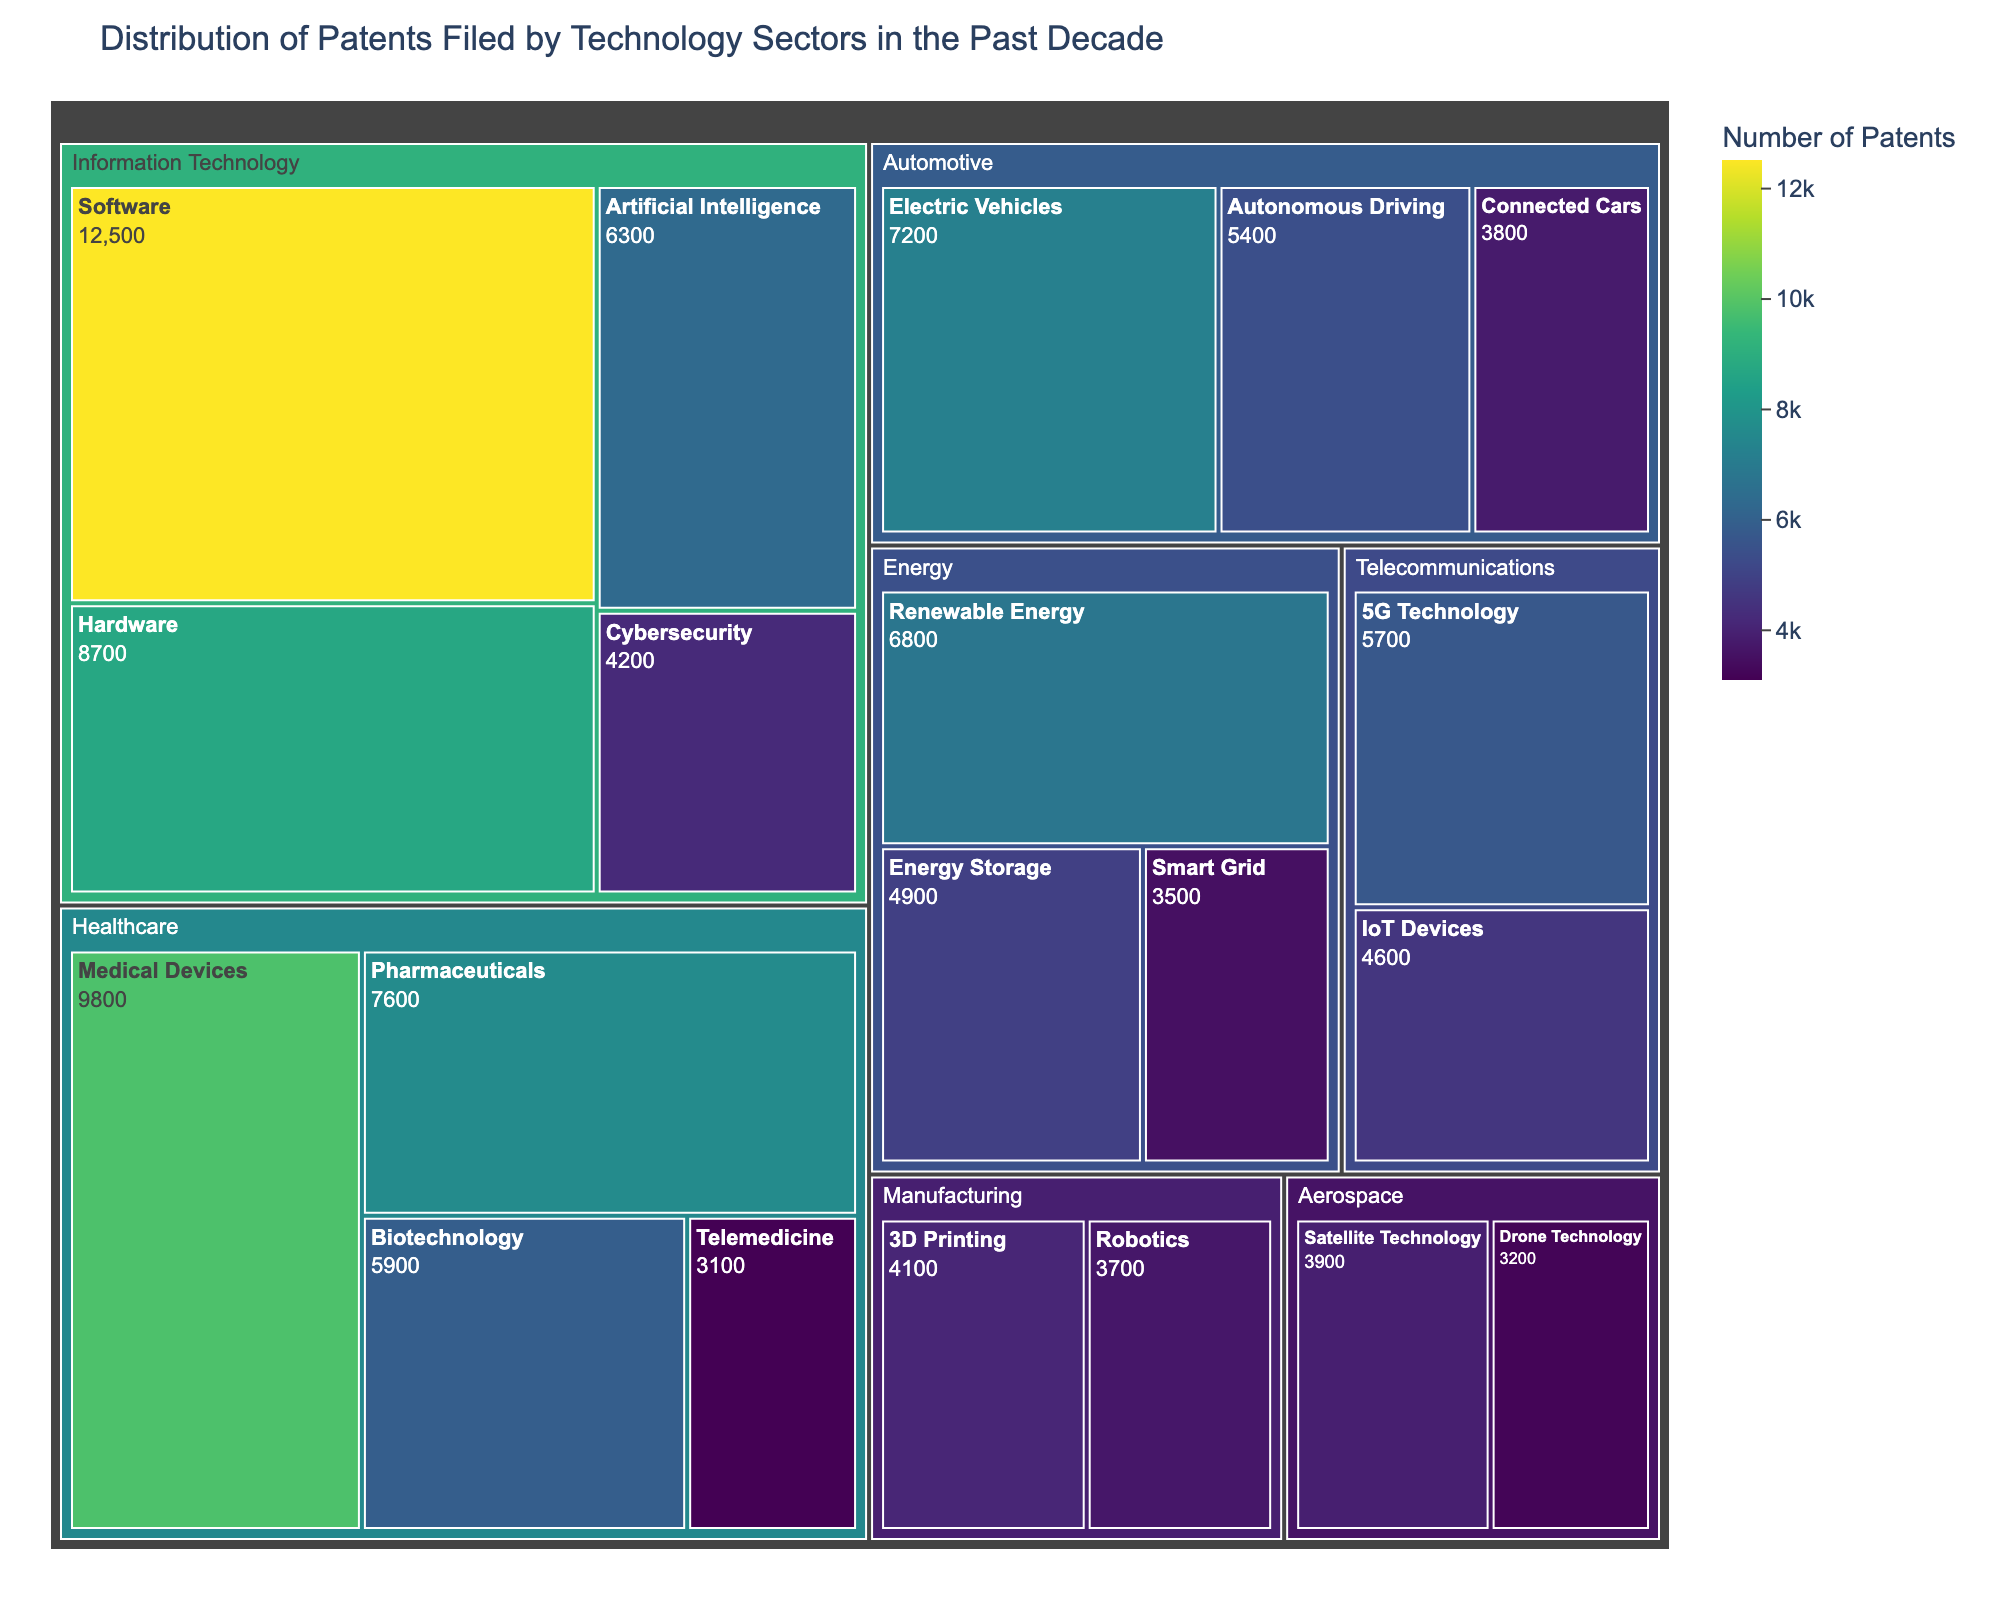what is the title of the treemap? The title of the treemap is located at the top and indicates the main topic or focus of the chart. By looking at the top of the figure, we can see the text that serves as the title.
Answer: Distribution of Patents Filed by Technology Sectors in the Past Decade Which sector has the highest number of patents? To determine the sector with the highest number of patents, observe the largest tile area in the treemap since the size of each tile represents the value of patents. The sector with the largest combined value when summing up its subcategories will have the highest count.
Answer: Information Technology How many patents are filed in the Healthcare sector? To find this, sum the number of patents in the subcategories within the Healthcare sector. The figures given are Medical Devices (9800), Pharmaceuticals (7600), Biotechnology (5900), and Telemedicine (3100). The calculation is 9800 + 7600 + 5900 + 3100.
Answer: 26400 Compare the number of patents filed in Artificial Intelligence and Cybersecurity. Which is higher and by how much? Identify the patent counts for both categories within the Information Technology sector. Artificial Intelligence has 6300 patents and Cybersecurity has 4200. So, we subtract 4200 from 6300 to find the difference.
Answer: Artificial Intelligence is higher by 2100 Which category in the Automotive sector has the least number of patents? Examine the subcategories within the Automotive sector to identify the one with the smallest number. The given figures are Electric Vehicles (7200), Autonomous Driving (5400), and Connected Cars (3800). The smallest of these is 3800 in Connected Cars.
Answer: Connected Cars How does the number of patents in 5G Technology compare to IoT Devices in the Telecommunications sector? Look at these two subcategories within Telecommunications. 5G Technology has 5700 and IoT Devices has 4600. Comparing the two figures shows which one is greater.
Answer: 5G Technology has more patents than IoT Devices What is the total number of patents filed in the Renewable Energy and Energy Storage categories combined? Add the number of patents in Renewable Energy (6800) and Energy Storage (4900) to get the combined total. The calculation is 6800 + 4900.
Answer: 11700 Which two sectors have almost equal numbers of patents, and what are their totals? Simply compare the total number of patents filed in each sector to find close values. By totaling the counts per sector and comparing, we find that Energy and Telecommunications have similar values.
Answer: Energy (15200) and Telecommunications (10300) What percentage of the total patents in the Healthcare sector does the Medical Devices category represent? First, sum all the patent counts in the Healthcare sector for the total (26400), then divide the Medical Devices count (9800) by this total and multiply by 100 for the percentage. Calculation: (9800 / 26400) * 100.
Answer: 37.12% Which technology sector has more diversity in subcategories based on the number of subcategories listed? Each sector's subcategories are listed, and counting these will show which one has the most.
Answer: Healthcare with 4 subcategories 